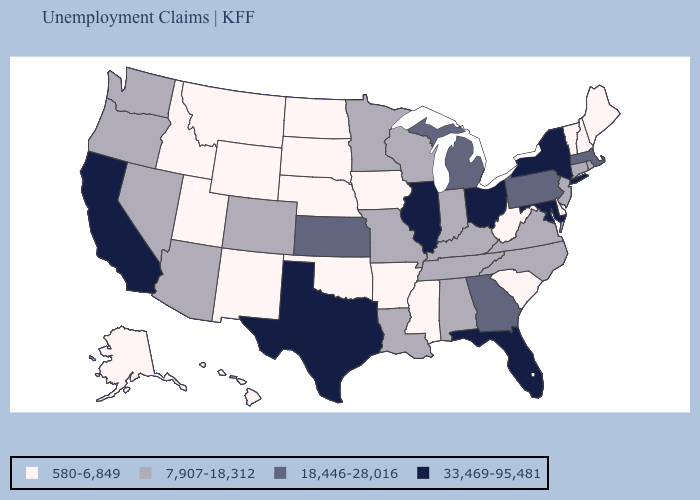What is the lowest value in the USA?
Answer briefly. 580-6,849. What is the value of Virginia?
Keep it brief. 7,907-18,312. Among the states that border Massachusetts , does New York have the highest value?
Give a very brief answer. Yes. Name the states that have a value in the range 18,446-28,016?
Be succinct. Georgia, Kansas, Massachusetts, Michigan, Pennsylvania. Name the states that have a value in the range 580-6,849?
Give a very brief answer. Alaska, Arkansas, Delaware, Hawaii, Idaho, Iowa, Maine, Mississippi, Montana, Nebraska, New Hampshire, New Mexico, North Dakota, Oklahoma, South Carolina, South Dakota, Utah, Vermont, West Virginia, Wyoming. What is the value of Delaware?
Short answer required. 580-6,849. Among the states that border Oklahoma , does Missouri have the lowest value?
Be succinct. No. Does Washington have the same value as Ohio?
Give a very brief answer. No. What is the lowest value in the USA?
Give a very brief answer. 580-6,849. Name the states that have a value in the range 580-6,849?
Answer briefly. Alaska, Arkansas, Delaware, Hawaii, Idaho, Iowa, Maine, Mississippi, Montana, Nebraska, New Hampshire, New Mexico, North Dakota, Oklahoma, South Carolina, South Dakota, Utah, Vermont, West Virginia, Wyoming. Among the states that border Iowa , does Illinois have the lowest value?
Concise answer only. No. What is the highest value in the USA?
Write a very short answer. 33,469-95,481. Does North Dakota have the same value as Montana?
Give a very brief answer. Yes. Does Iowa have the lowest value in the USA?
Quick response, please. Yes. Does Oregon have the lowest value in the USA?
Quick response, please. No. 